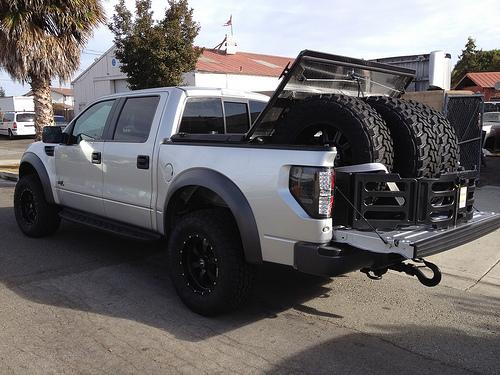What type of transportation is portrayed in the image, and what is its purpose? The image portrays a pickup truck, which is likely used for personal transportation or carrying cargo such as the oversized tires in its bed. Mention any natural elements present in the image. There are a palm tree, a green tree, and brown leaves on the palm tree in the image. Are there any buildings in the image? If yes, mention their most noticeable features. Yes, there is a building with a red roof, and there is a flag on top of it. Is there any evidence of nationalism displayed in the image? If so, describe it briefly. Yes, an American flag is flying on a pole in the background of the image. What is the primary object in the image and describe it briefly. A silver four-door truck is the primary object, with tinted windows, a lowered tailgate, and oversized black tires in its bed. Describe the scene depicted in the image based on the elements present. The image shows a silver four-door pickup truck parked on a side street, with oversized black tires loaded in its bed, various trees in the background, and a building with a red roof and an American flag atop it. Count the total number of tires mentioned in the image information. There are 8 tires in total: rear driver tire, front driver tire, 3 oversized tires in bed, and 2 jet black wheels. Provide a detailed description of the scene or location shown in the image. A silver four-door pickup truck is parked on a side street with its tailgate lowered, revealing large black tires in the bed. There are various trees and a building with a red roof and an American flag in the background. Identify the type of vehicle and its most noticeable feature. The image shows a silver pickup truck with large, oversized black tires loaded on its truck bed. What is the most prominent color used for vehicles in the image? Silver is the most prominent color, as there is a silver pickup truck and a white minivan. Is there a yellow tree in the distance? The trees described in the image are a green tree and a palm tree, not a yellow tree. Is there a blue pickup truck in the image? The object described in the image is a silver pickup truck, not a blue one. Is there a purple-roofed building in the background? The roof color of the building mentioned in the image is red, not purple. Can you see a small regular-sized tire in the bed of the truck? The image contains oversized black tires in the bed of the truck, not small regular-sized ones. Are there four tires on the rear axle of the truck? The image shows only one tire on the rear axle of the truck, not four. Can you find a sunroof on the truck's roof? No sunroof is described for the truck in the image. 